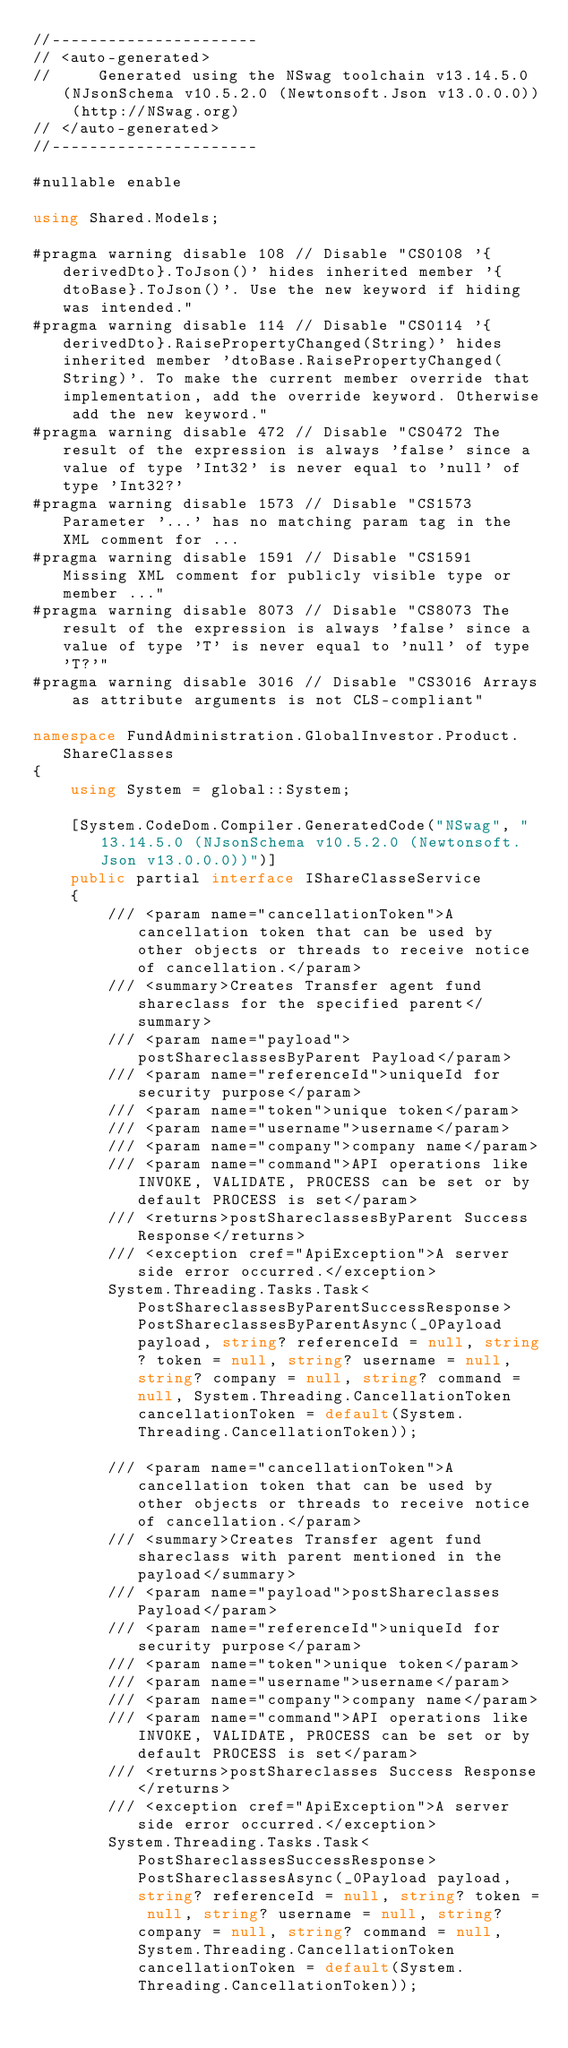Convert code to text. <code><loc_0><loc_0><loc_500><loc_500><_C#_>//----------------------
// <auto-generated>
//     Generated using the NSwag toolchain v13.14.5.0 (NJsonSchema v10.5.2.0 (Newtonsoft.Json v13.0.0.0)) (http://NSwag.org)
// </auto-generated>
//----------------------

#nullable enable

using Shared.Models;

#pragma warning disable 108 // Disable "CS0108 '{derivedDto}.ToJson()' hides inherited member '{dtoBase}.ToJson()'. Use the new keyword if hiding was intended."
#pragma warning disable 114 // Disable "CS0114 '{derivedDto}.RaisePropertyChanged(String)' hides inherited member 'dtoBase.RaisePropertyChanged(String)'. To make the current member override that implementation, add the override keyword. Otherwise add the new keyword."
#pragma warning disable 472 // Disable "CS0472 The result of the expression is always 'false' since a value of type 'Int32' is never equal to 'null' of type 'Int32?'
#pragma warning disable 1573 // Disable "CS1573 Parameter '...' has no matching param tag in the XML comment for ...
#pragma warning disable 1591 // Disable "CS1591 Missing XML comment for publicly visible type or member ..."
#pragma warning disable 8073 // Disable "CS8073 The result of the expression is always 'false' since a value of type 'T' is never equal to 'null' of type 'T?'"
#pragma warning disable 3016 // Disable "CS3016 Arrays as attribute arguments is not CLS-compliant"

namespace FundAdministration.GlobalInvestor.Product.ShareClasses
{
    using System = global::System;

    [System.CodeDom.Compiler.GeneratedCode("NSwag", "13.14.5.0 (NJsonSchema v10.5.2.0 (Newtonsoft.Json v13.0.0.0))")]
    public partial interface IShareClasseService
    {
        /// <param name="cancellationToken">A cancellation token that can be used by other objects or threads to receive notice of cancellation.</param>
        /// <summary>Creates Transfer agent fund shareclass for the specified parent</summary>
        /// <param name="payload">postShareclassesByParent Payload</param>
        /// <param name="referenceId">uniqueId for security purpose</param>
        /// <param name="token">unique token</param>
        /// <param name="username">username</param>
        /// <param name="company">company name</param>
        /// <param name="command">API operations like INVOKE, VALIDATE, PROCESS can be set or by default PROCESS is set</param>
        /// <returns>postShareclassesByParent Success Response</returns>
        /// <exception cref="ApiException">A server side error occurred.</exception>
        System.Threading.Tasks.Task<PostShareclassesByParentSuccessResponse> PostShareclassesByParentAsync(_0Payload payload, string? referenceId = null, string? token = null, string? username = null, string? company = null, string? command = null, System.Threading.CancellationToken cancellationToken = default(System.Threading.CancellationToken));
    
        /// <param name="cancellationToken">A cancellation token that can be used by other objects or threads to receive notice of cancellation.</param>
        /// <summary>Creates Transfer agent fund shareclass with parent mentioned in the payload</summary>
        /// <param name="payload">postShareclasses Payload</param>
        /// <param name="referenceId">uniqueId for security purpose</param>
        /// <param name="token">unique token</param>
        /// <param name="username">username</param>
        /// <param name="company">company name</param>
        /// <param name="command">API operations like INVOKE, VALIDATE, PROCESS can be set or by default PROCESS is set</param>
        /// <returns>postShareclasses Success Response</returns>
        /// <exception cref="ApiException">A server side error occurred.</exception>
        System.Threading.Tasks.Task<PostShareclassesSuccessResponse> PostShareclassesAsync(_0Payload payload, string? referenceId = null, string? token = null, string? username = null, string? company = null, string? command = null, System.Threading.CancellationToken cancellationToken = default(System.Threading.CancellationToken));
    </code> 